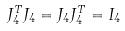Convert formula to latex. <formula><loc_0><loc_0><loc_500><loc_500>J _ { 4 } ^ { T } J _ { 4 } = J _ { 4 } J _ { 4 } ^ { T } = I _ { 4 }</formula> 